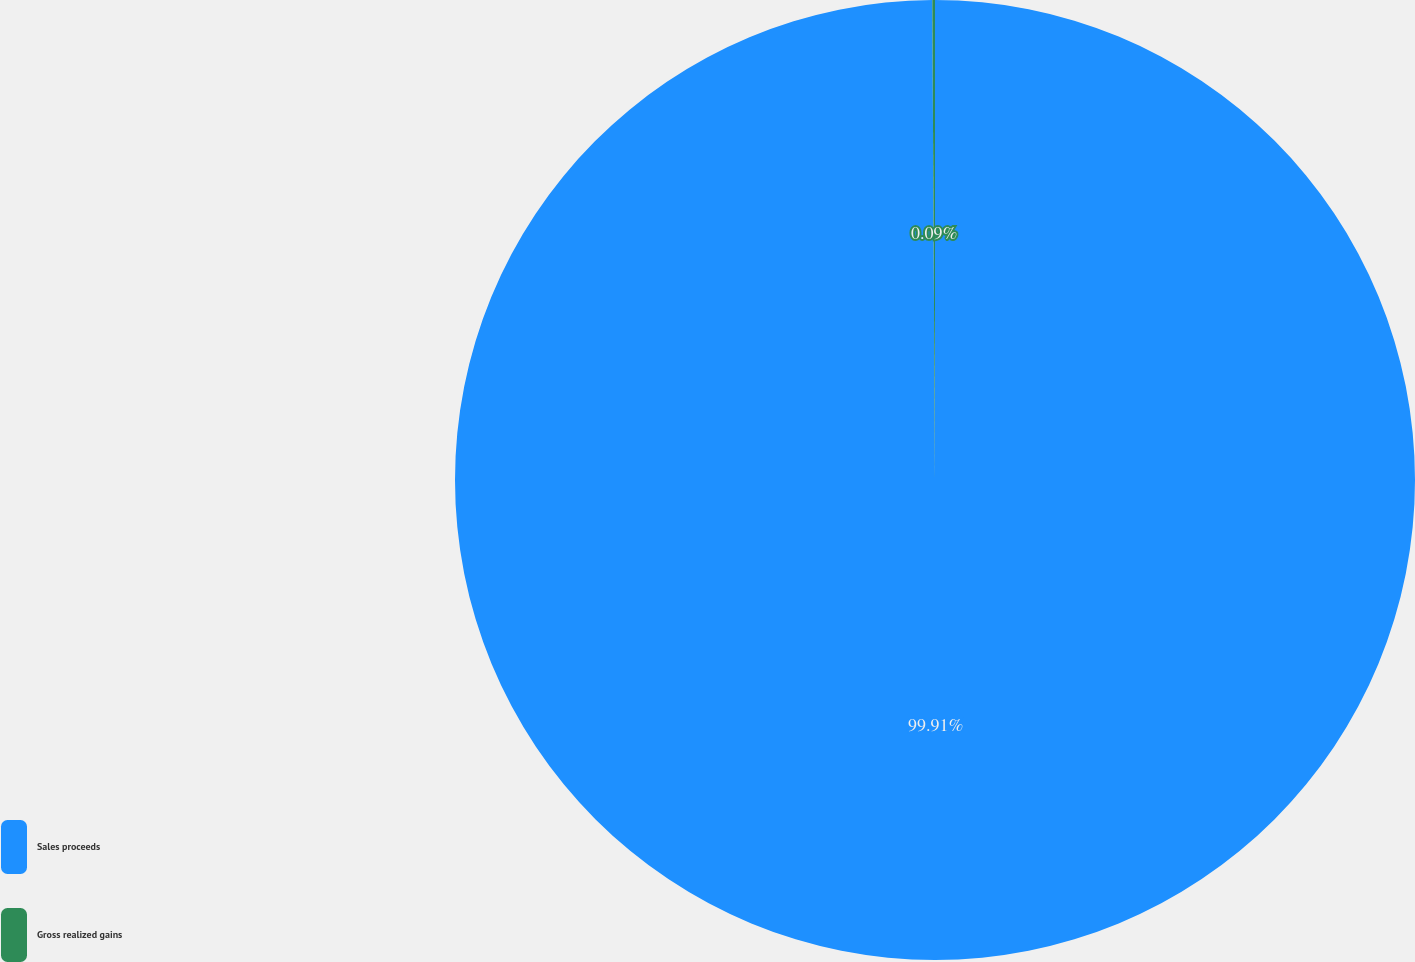Convert chart to OTSL. <chart><loc_0><loc_0><loc_500><loc_500><pie_chart><fcel>Sales proceeds<fcel>Gross realized gains<nl><fcel>99.91%<fcel>0.09%<nl></chart> 